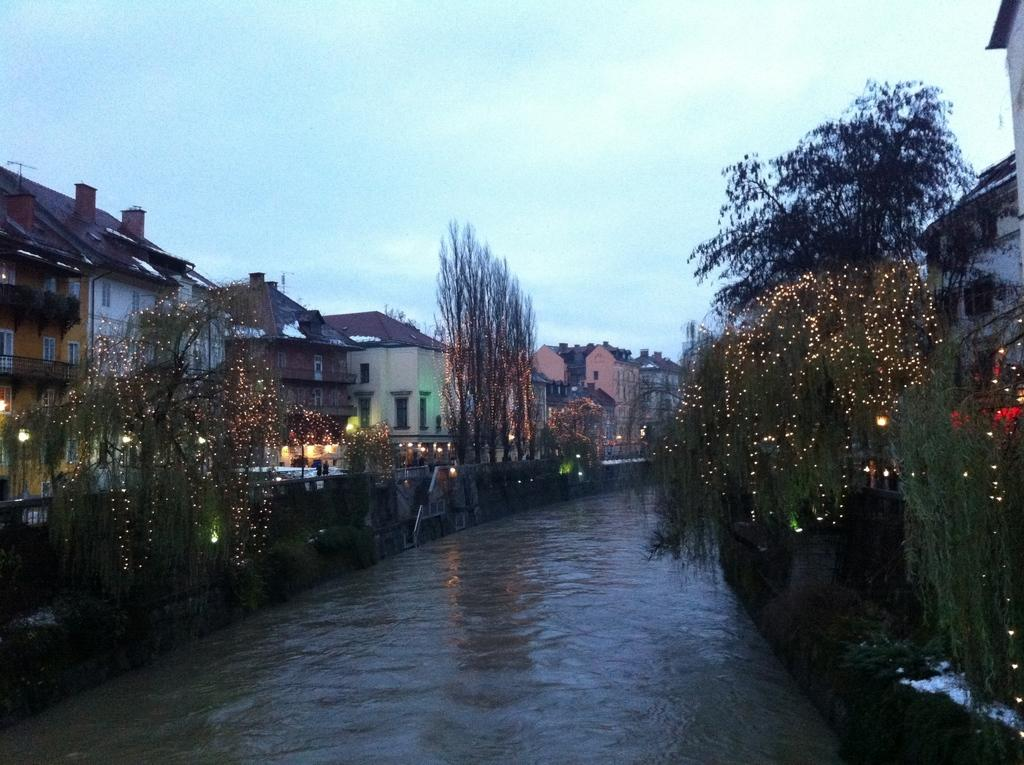What is present in the image that represents a natural element? There is water and trees in the image, which represent natural elements. What type of man-made structures can be seen in the image? There are buildings in the image. What type of pathway is visible in the image? There is a road in the image. What type of illumination is present in the image? There are lights in the image. What part of the natural environment is visible in the image? The sky is visible in the image, and there are clouds in the sky. What type of maid is depicted in the image? There is no maid present in the image. What type of trouble is being caused by the clouds in the image? The clouds in the image are not causing any trouble; they are simply part of the natural environment. 